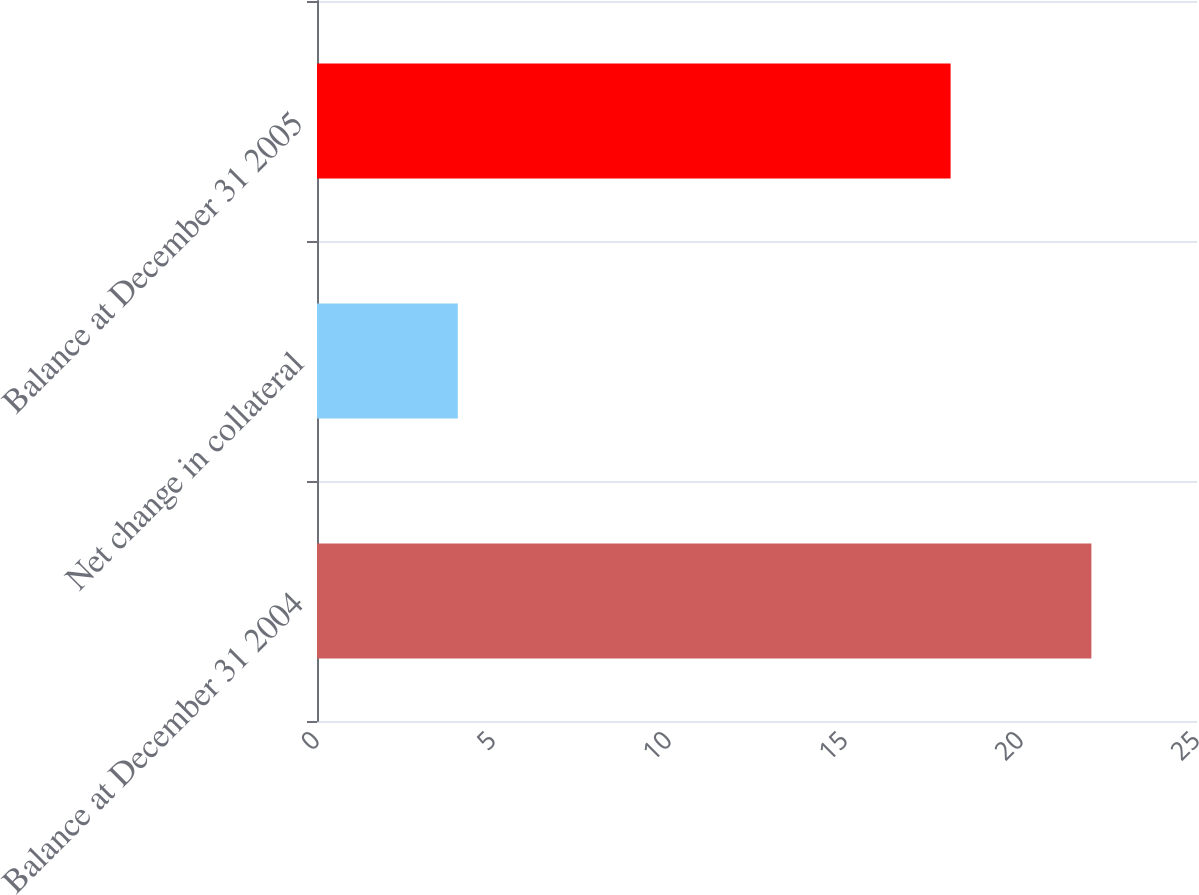Convert chart. <chart><loc_0><loc_0><loc_500><loc_500><bar_chart><fcel>Balance at December 31 2004<fcel>Net change in collateral<fcel>Balance at December 31 2005<nl><fcel>22<fcel>4<fcel>18<nl></chart> 